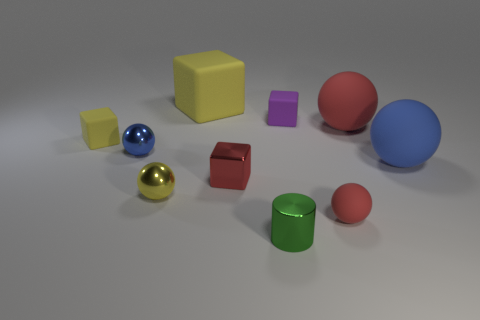Subtract all large yellow rubber cubes. How many cubes are left? 3 Subtract 1 spheres. How many spheres are left? 4 Subtract all purple blocks. How many blocks are left? 3 Subtract all gray cubes. Subtract all cyan balls. How many cubes are left? 4 Subtract all cubes. How many objects are left? 6 Add 5 yellow matte objects. How many yellow matte objects exist? 7 Subtract 0 brown balls. How many objects are left? 10 Subtract all small red matte things. Subtract all tiny matte blocks. How many objects are left? 7 Add 8 red balls. How many red balls are left? 10 